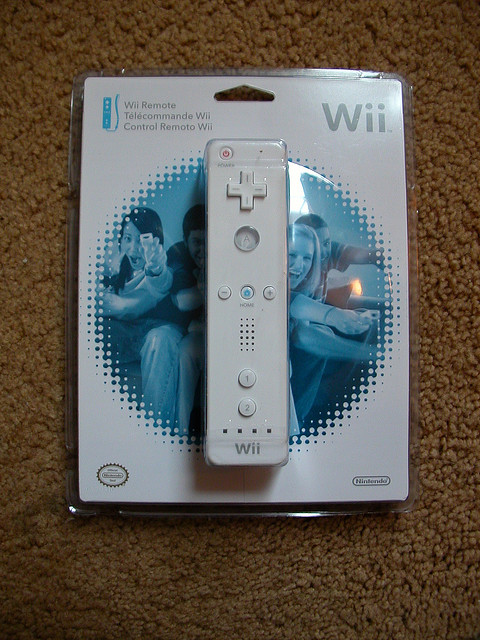Please transcribe the text in this image. Wii Wii Control Remote Wii 2 I Wii Remote Telecommande will 